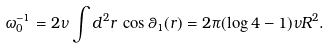<formula> <loc_0><loc_0><loc_500><loc_500>\omega _ { 0 } ^ { - 1 } = 2 \nu \int d ^ { 2 } r \, \cos \theta _ { 1 } ( r ) = 2 \pi ( \log 4 - 1 ) \nu R ^ { 2 } .</formula> 